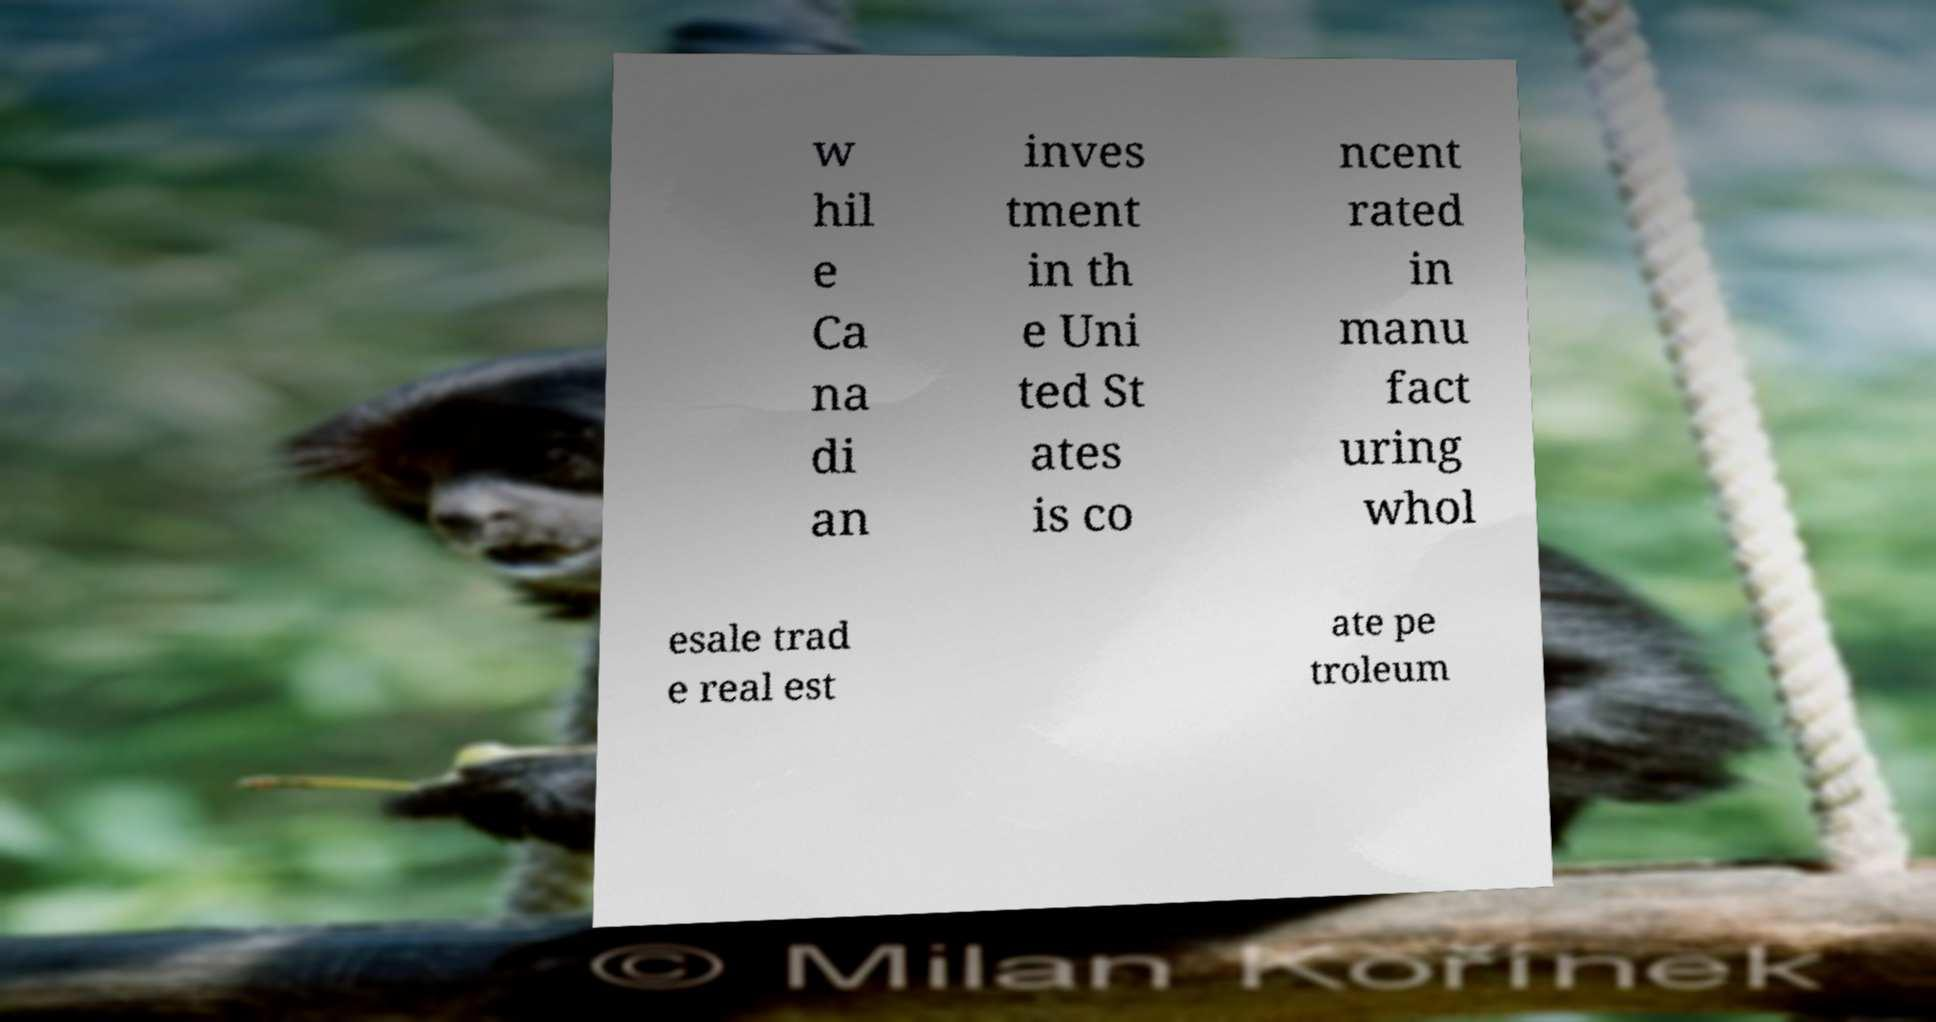Can you accurately transcribe the text from the provided image for me? w hil e Ca na di an inves tment in th e Uni ted St ates is co ncent rated in manu fact uring whol esale trad e real est ate pe troleum 